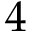<formula> <loc_0><loc_0><loc_500><loc_500>4</formula> 